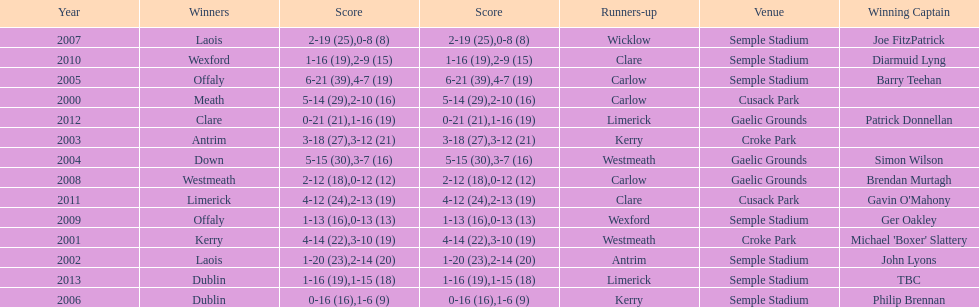Who was the first winner in 2013? Dublin. 